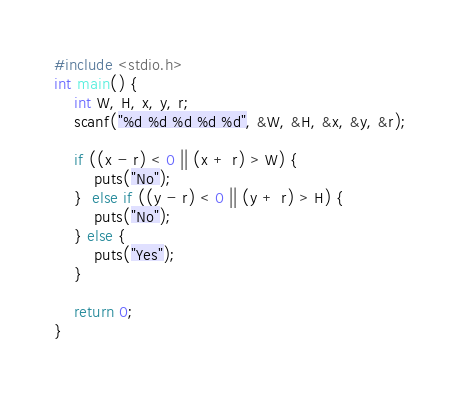Convert code to text. <code><loc_0><loc_0><loc_500><loc_500><_C_>#include <stdio.h>
int main() {
    int W, H, x, y, r;
    scanf("%d %d %d %d %d", &W, &H, &x, &y, &r);

    if ((x - r) < 0 || (x + r) > W) {
        puts("No");
    }  else if ((y - r) < 0 || (y + r) > H) {
        puts("No");
    } else {
        puts("Yes");
    }

    return 0;
}</code> 